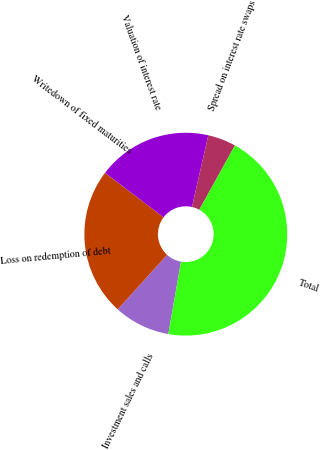Convert chart. <chart><loc_0><loc_0><loc_500><loc_500><pie_chart><fcel>Investment sales and calls<fcel>Loss on redemption of debt<fcel>Writedown of fixed maturities<fcel>Valuation of interest rate<fcel>Spread on interest rate swaps<fcel>Total<nl><fcel>8.96%<fcel>23.61%<fcel>0.02%<fcel>18.22%<fcel>4.49%<fcel>44.71%<nl></chart> 